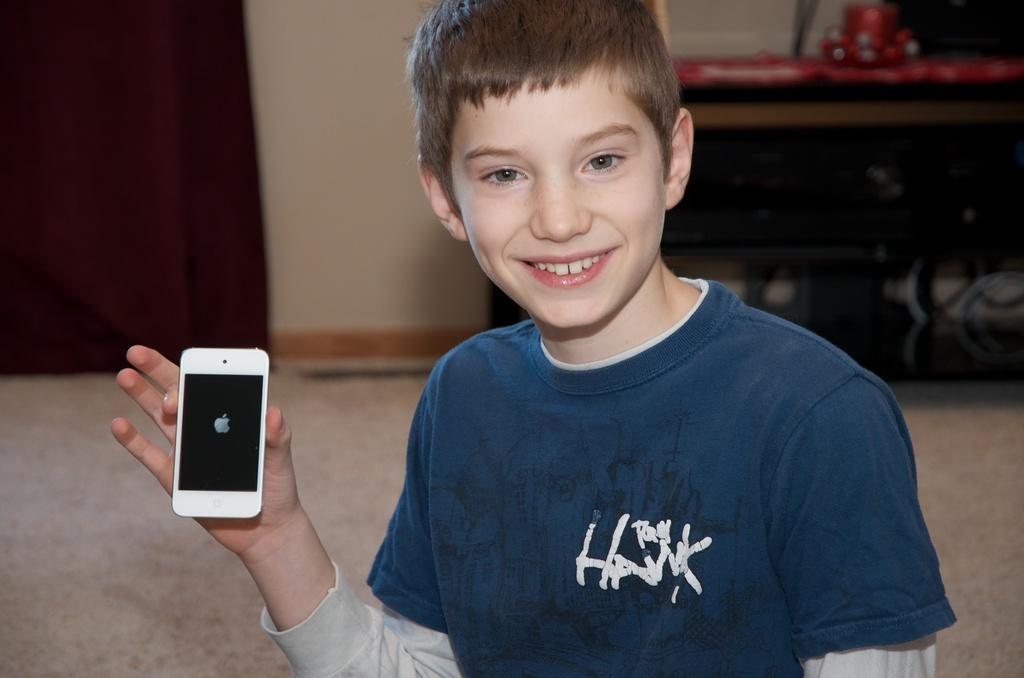What can be seen in the background of the image? There is a wall in the image. Who is present in the image? There is a boy in the image. What is the boy holding in the image? The boy is holding a mobile phone. What type of suit is the boy wearing in the image? There is no suit visible in the image; the boy is wearing regular clothing. Can you describe the trail that leads to the yard in the image? There is no yard or trail present in the image; it only features a wall and a boy holding a mobile phone. 